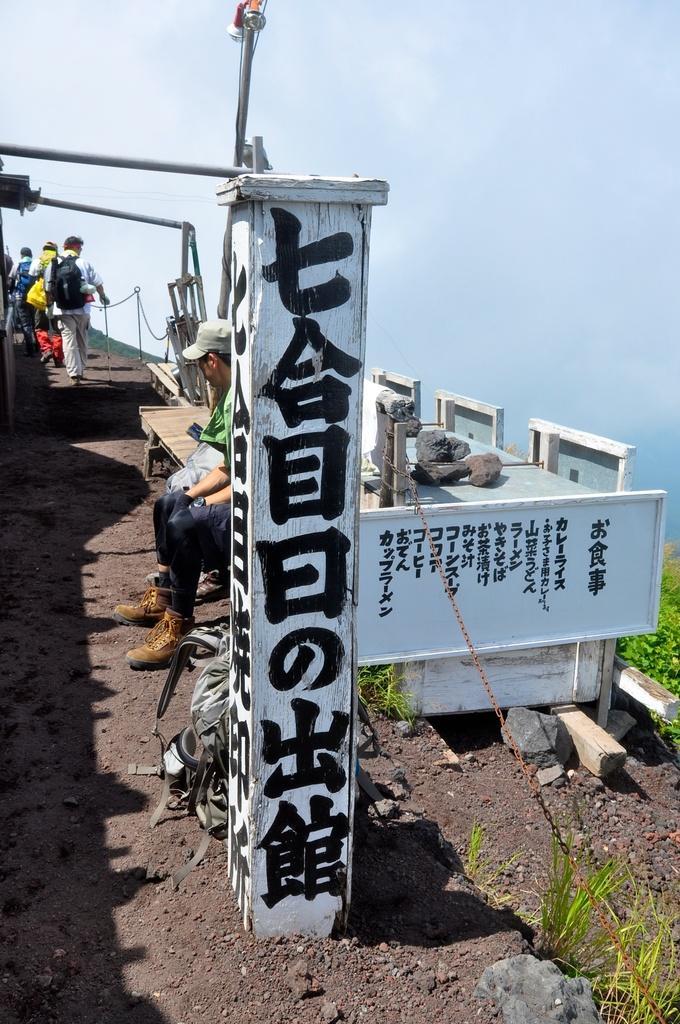How would you summarize this image in a sentence or two? In this image I can see few people are wearing bags and walking. One person is sitting on the wooden bench. In front I can see wooden wall and something is written on it with black color. The sky is in blue and white color. We can see green grass. 